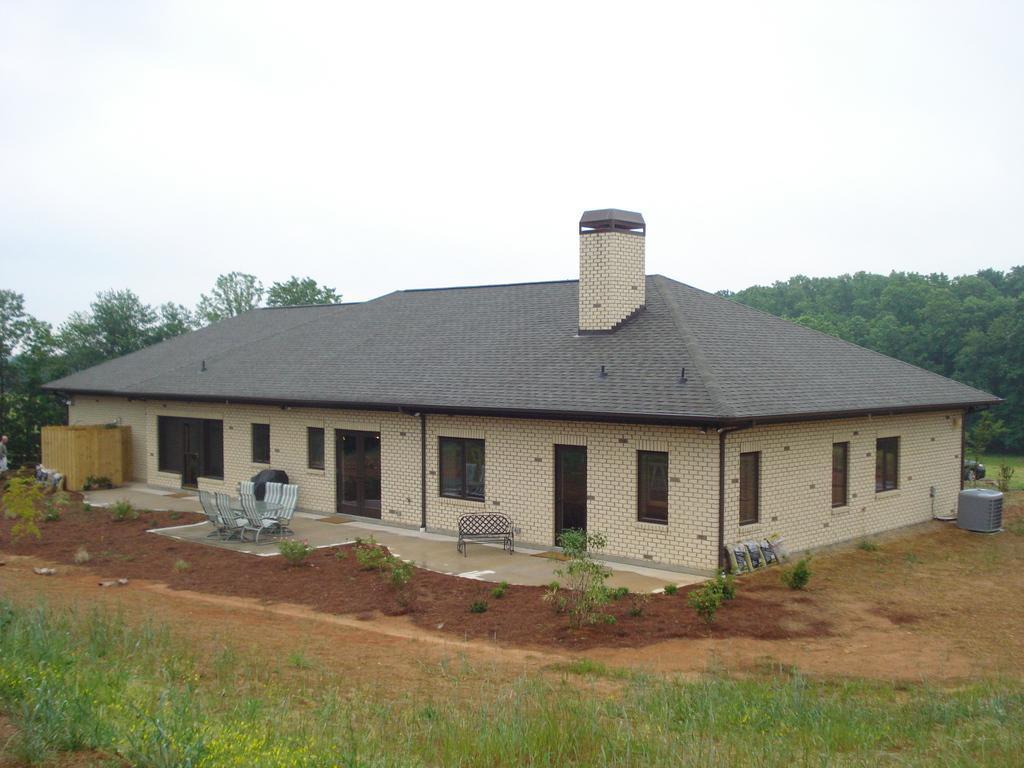How would you summarize this image in a sentence or two? This image is clicked outside. There is a house in the middle. There are chairs in the middle. That house has windows and doors. There are trees on the left side and right side. There is grass at the bottom. There is sky at the top. 